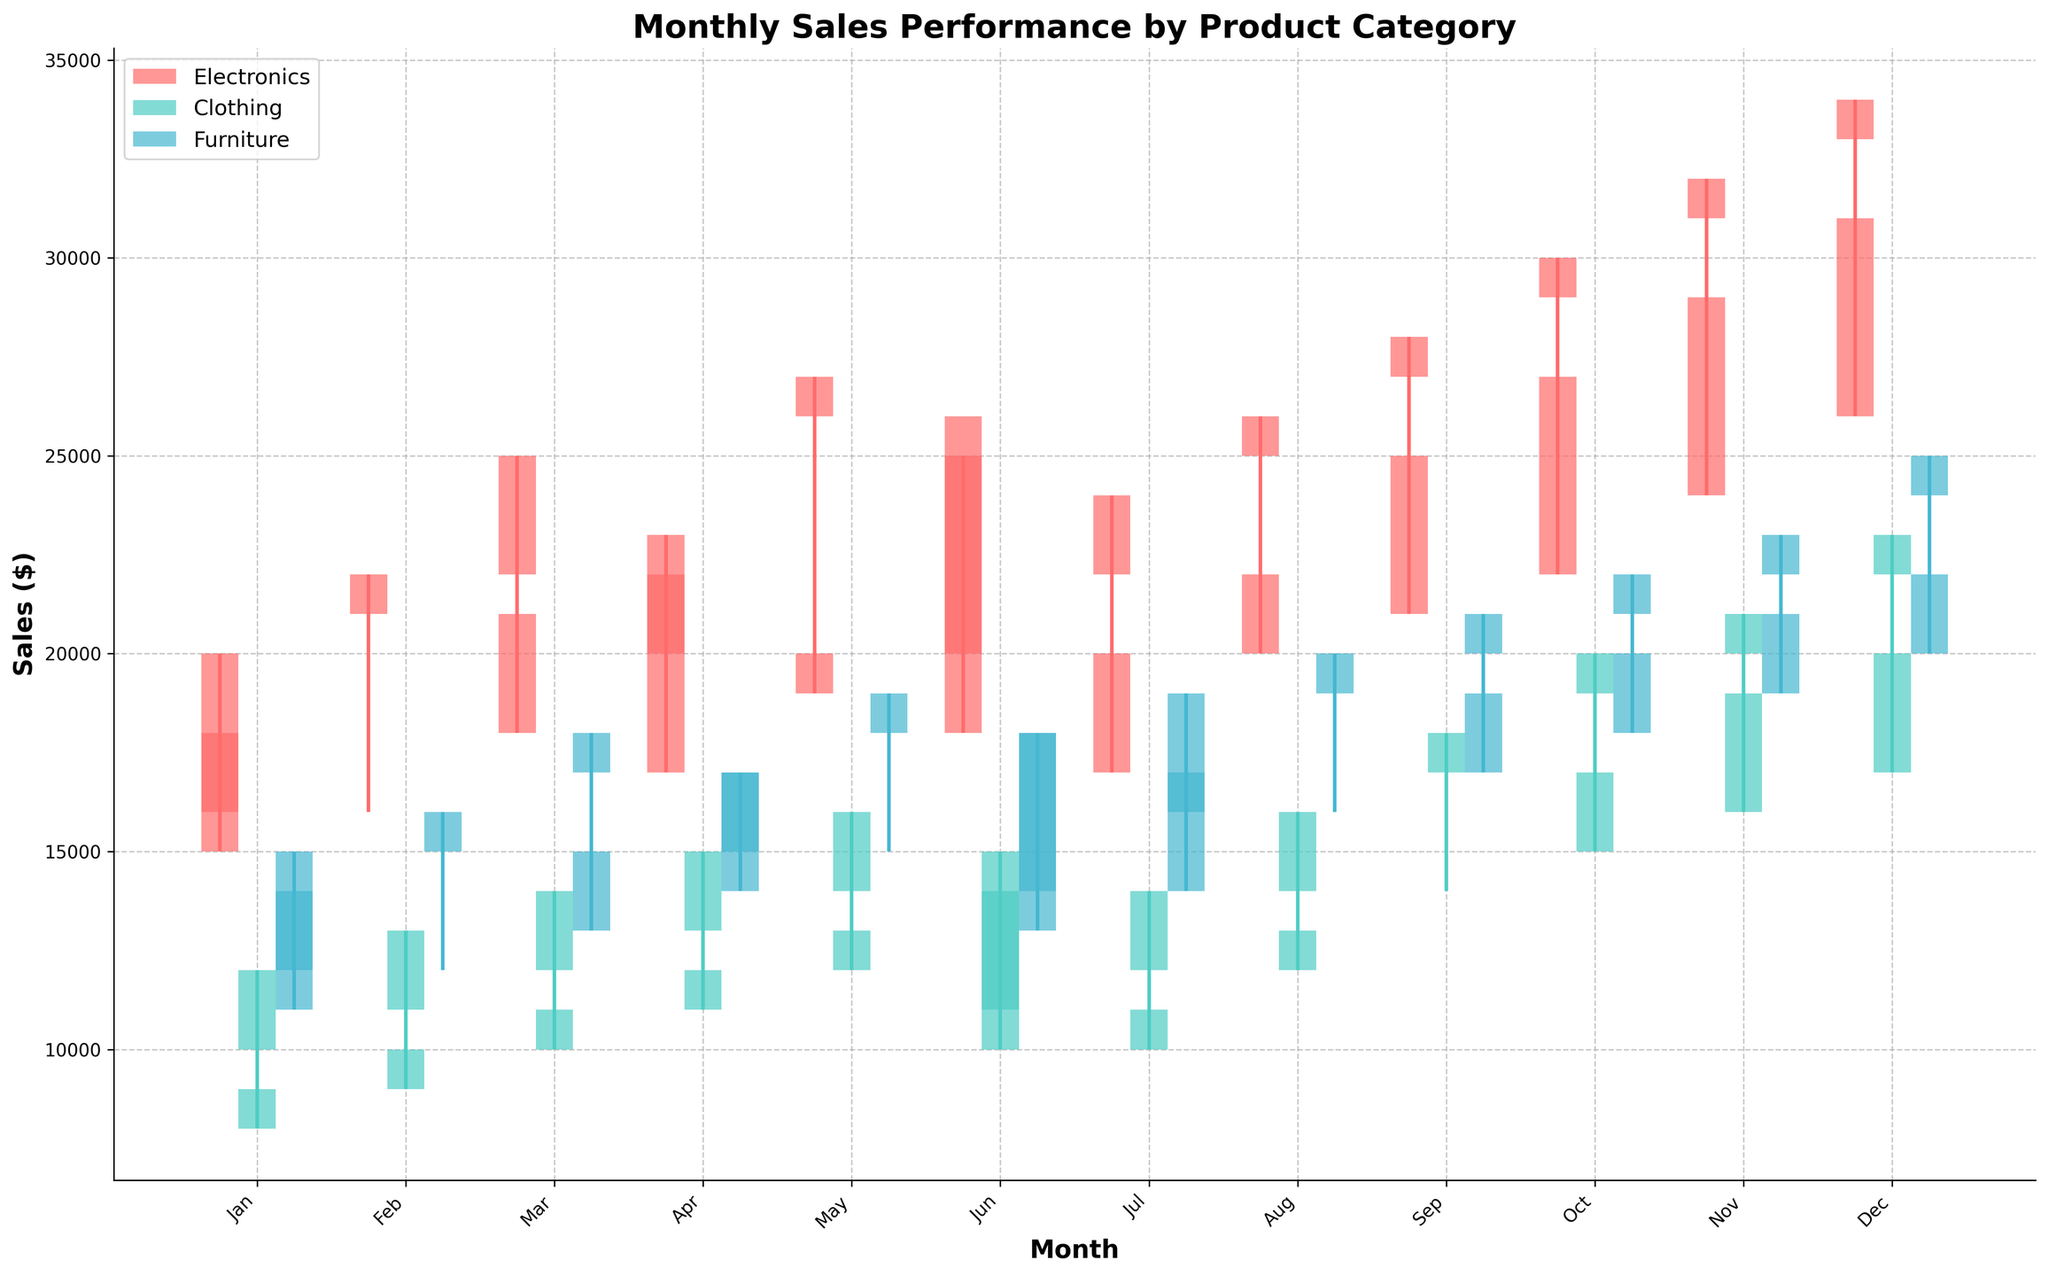What is the title of the figure? The title of the figure is usually displayed at the top. It provides a summary of what the figure represents. Looking at the provided description, the title is "Monthly Sales Performance by Product Category".
Answer: Monthly Sales Performance by Product Category What are the categories displayed in the figure? The categories are typically shown in the legend, which helps identify different segments in the figure. According to the provided script, the categories are Electronics, Clothing, and Furniture.
Answer: Electronics, Clothing, Furniture Which month had the highest high sales for Electronics? To determine this, compare the highest 'High Sales' value across all months for the Electronics category. According to the data, December had the highest high sale at $34,000.
Answer: December In which category did sales drop the most in June? Sales drop is the difference between 'Open Sales' and 'Close Sales'. For June, the drop for Electronics is (26000-20000)=6000, Clothing is (14000-11000)=3000, and Furniture is (18000-14000)=4000. Electronics had the highest drop at 6000.
Answer: Electronics What is the average low sales for Clothing from Jan to Jun? Sum all 'Low Sales' values for Clothing from Jan to Jun and divide by the number of months (6). (8000 + 9000 + 10000 + 11000 + 12000 + 10000) / 6 = 60000 / 6 = 10000.
Answer: 10000 Which product category had sales close at their highest value in October? The 'Close Sales' values need to be compared for all categories for October. Electronics closed at $29,000, Clothing at $19,000, and Furniture at $21,000. Electronics had the highest close.
Answer: Electronics How did the high sales for Furniture in December compare to the high sales in January? Compare the 'High Sales' values for Furniture in December ($25,000) and January ($15,000). December's high sales were $10,000 higher than January's.
Answer: December was $10,000 higher What was the trend in monthly close sales for Electronics from Jan to Dec? Identify the closing sales for Electronics in each month and observe the general trend. The values are: 16000, 21000, 22000, 20000, 26000, 20000, 22000, 25000, 27000, 29000, 31000, 33000. The trend shows a general increase over the months.
Answer: Increasing Which month saw the lowest low sales for Furniture? Look for the month with the lowest 'Low Sales' value for Furniture. According to the data, January had the lowest low sales at $11,000.
Answer: January 